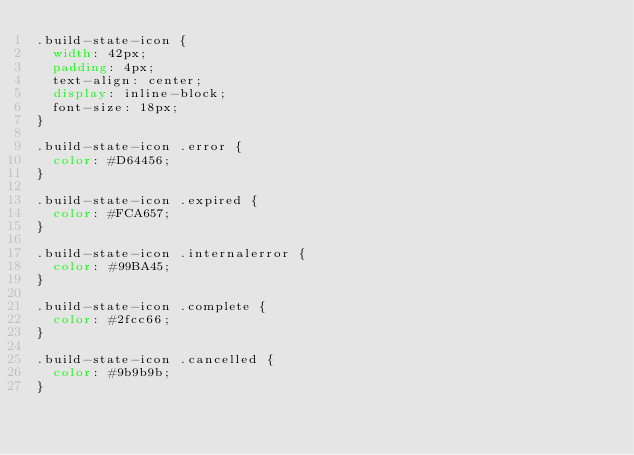<code> <loc_0><loc_0><loc_500><loc_500><_CSS_>.build-state-icon {
  width: 42px;
  padding: 4px;
  text-align: center;
  display: inline-block;
  font-size: 18px;
}

.build-state-icon .error {
  color: #D64456;
}

.build-state-icon .expired {
  color: #FCA657;
}

.build-state-icon .internalerror {
  color: #99BA45;
}

.build-state-icon .complete {
  color: #2fcc66;
}

.build-state-icon .cancelled {
  color: #9b9b9b;
}
</code> 